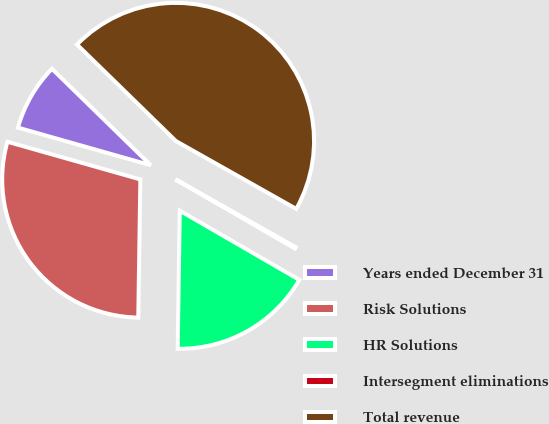Convert chart to OTSL. <chart><loc_0><loc_0><loc_500><loc_500><pie_chart><fcel>Years ended December 31<fcel>Risk Solutions<fcel>HR Solutions<fcel>Intersegment eliminations<fcel>Total revenue<nl><fcel>7.91%<fcel>29.15%<fcel>16.89%<fcel>0.18%<fcel>45.86%<nl></chart> 